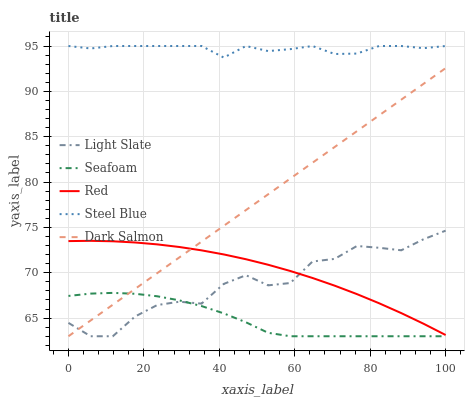Does Seafoam have the minimum area under the curve?
Answer yes or no. Yes. Does Steel Blue have the maximum area under the curve?
Answer yes or no. Yes. Does Dark Salmon have the minimum area under the curve?
Answer yes or no. No. Does Dark Salmon have the maximum area under the curve?
Answer yes or no. No. Is Dark Salmon the smoothest?
Answer yes or no. Yes. Is Light Slate the roughest?
Answer yes or no. Yes. Is Seafoam the smoothest?
Answer yes or no. No. Is Seafoam the roughest?
Answer yes or no. No. Does Light Slate have the lowest value?
Answer yes or no. Yes. Does Red have the lowest value?
Answer yes or no. No. Does Steel Blue have the highest value?
Answer yes or no. Yes. Does Dark Salmon have the highest value?
Answer yes or no. No. Is Seafoam less than Steel Blue?
Answer yes or no. Yes. Is Steel Blue greater than Seafoam?
Answer yes or no. Yes. Does Light Slate intersect Dark Salmon?
Answer yes or no. Yes. Is Light Slate less than Dark Salmon?
Answer yes or no. No. Is Light Slate greater than Dark Salmon?
Answer yes or no. No. Does Seafoam intersect Steel Blue?
Answer yes or no. No. 